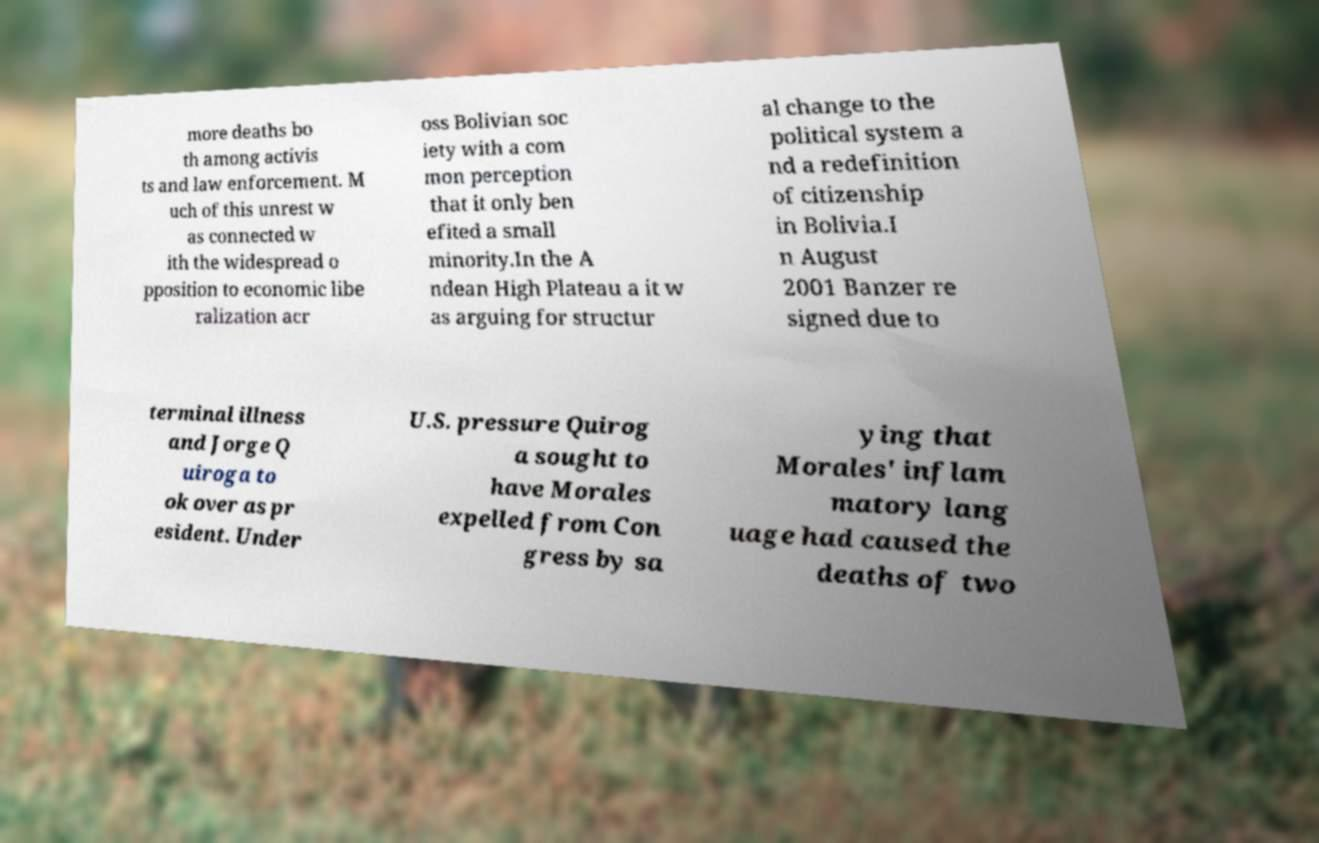What messages or text are displayed in this image? I need them in a readable, typed format. more deaths bo th among activis ts and law enforcement. M uch of this unrest w as connected w ith the widespread o pposition to economic libe ralization acr oss Bolivian soc iety with a com mon perception that it only ben efited a small minority.In the A ndean High Plateau a it w as arguing for structur al change to the political system a nd a redefinition of citizenship in Bolivia.I n August 2001 Banzer re signed due to terminal illness and Jorge Q uiroga to ok over as pr esident. Under U.S. pressure Quirog a sought to have Morales expelled from Con gress by sa ying that Morales' inflam matory lang uage had caused the deaths of two 